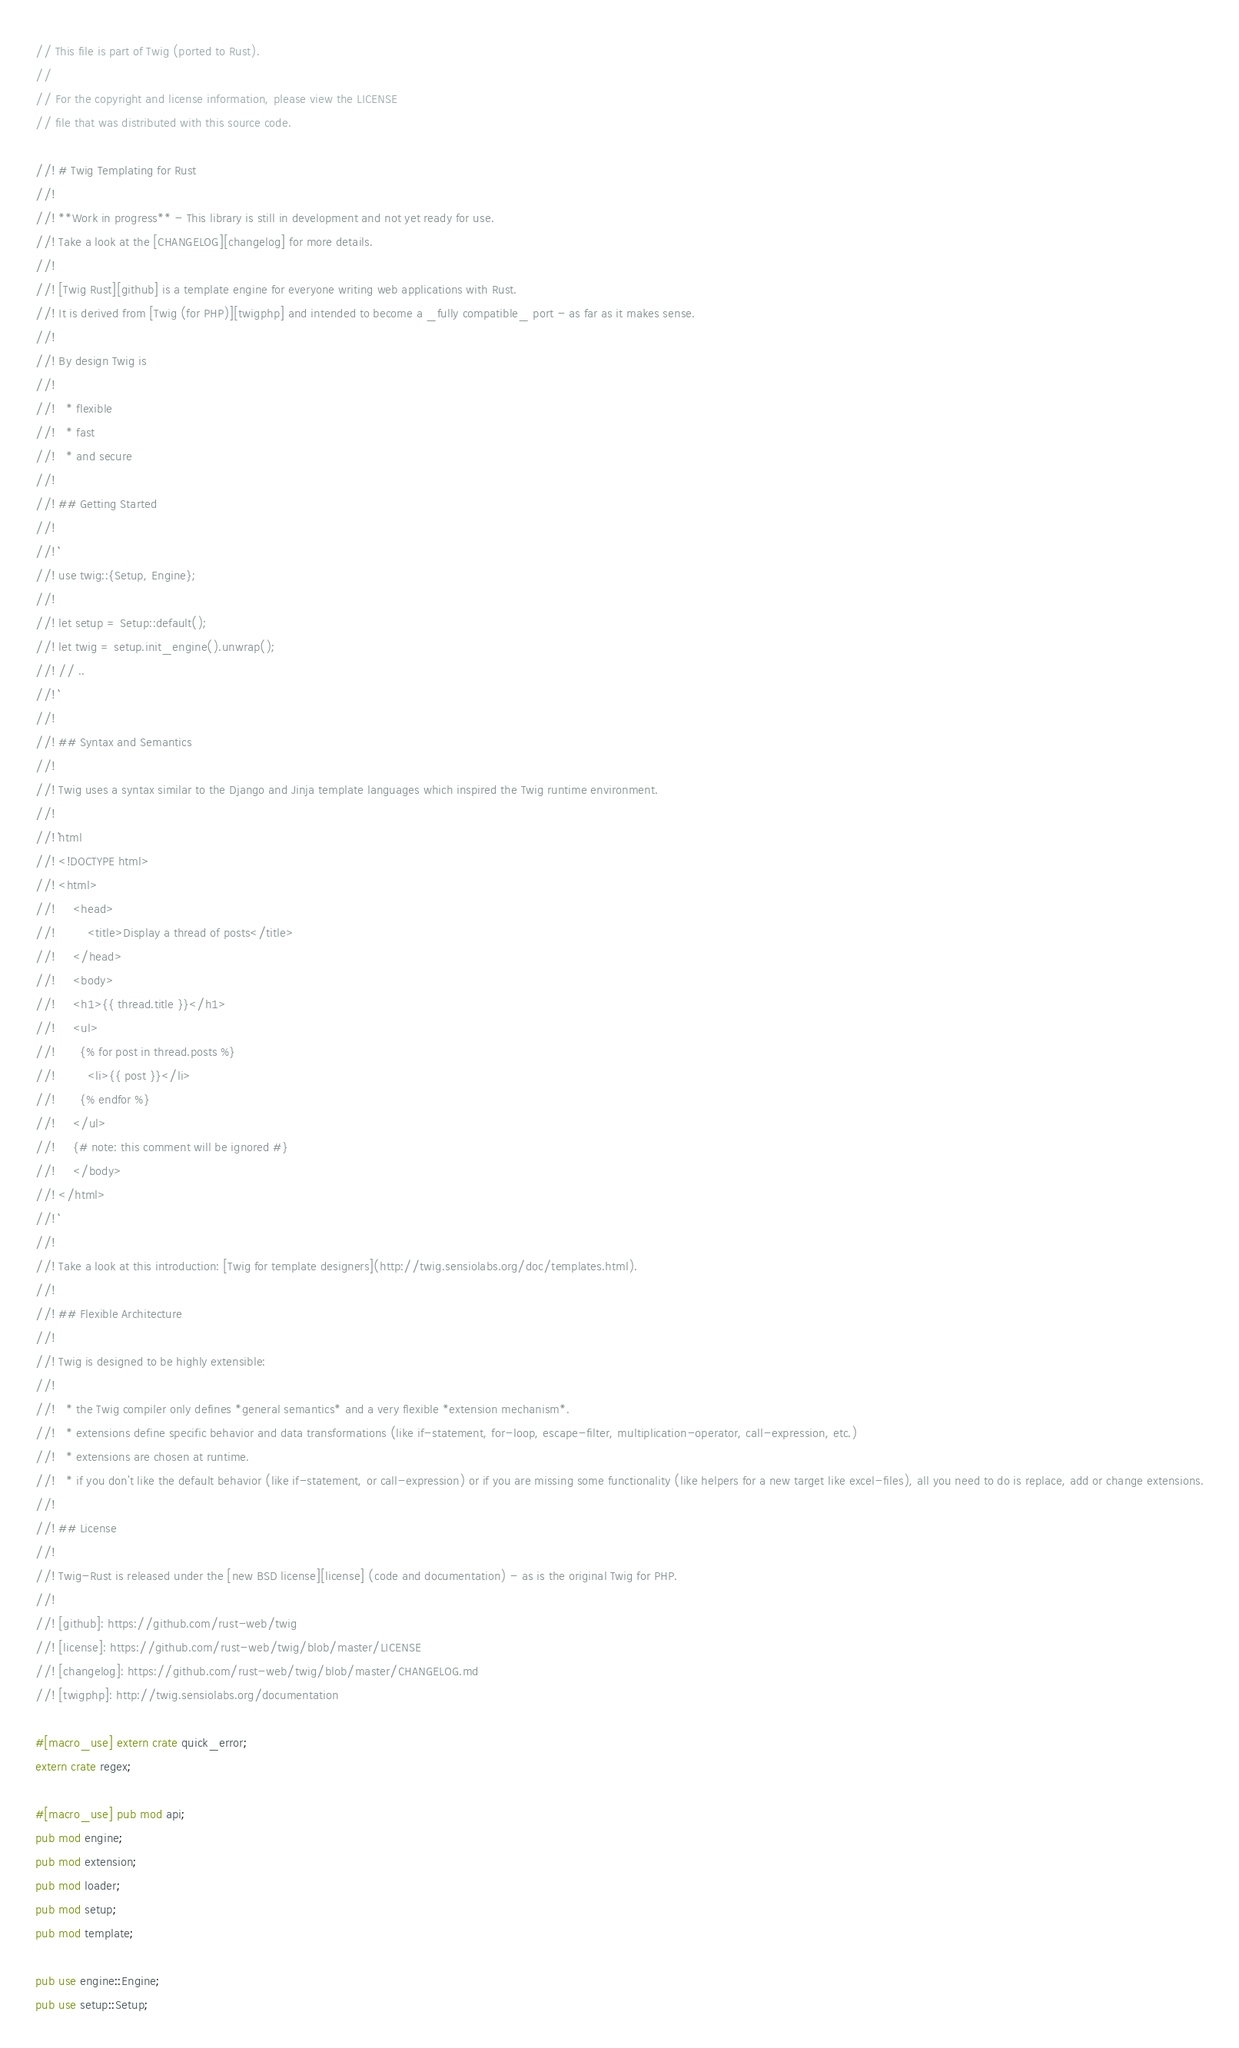Convert code to text. <code><loc_0><loc_0><loc_500><loc_500><_Rust_>// This file is part of Twig (ported to Rust).
//
// For the copyright and license information, please view the LICENSE
// file that was distributed with this source code.

//! # Twig Templating for Rust
//!
//! **Work in progress** - This library is still in development and not yet ready for use.
//! Take a look at the [CHANGELOG][changelog] for more details.
//!
//! [Twig Rust][github] is a template engine for everyone writing web applications with Rust.
//! It is derived from [Twig (for PHP)][twigphp] and intended to become a _fully compatible_ port - as far as it makes sense.
//!
//! By design Twig is
//!
//!   * flexible
//!   * fast
//!   * and secure
//!
//! ## Getting Started
//!
//! ```
//! use twig::{Setup, Engine};
//!
//! let setup = Setup::default();
//! let twig = setup.init_engine().unwrap();
//! // ..
//! ```
//!
//! ## Syntax and Semantics
//!
//! Twig uses a syntax similar to the Django and Jinja template languages which inspired the Twig runtime environment.
//!
//! ```html
//! <!DOCTYPE html>
//! <html>
//!     <head>
//!         <title>Display a thread of posts</title>
//!     </head>
//!     <body>
//!     <h1>{{ thread.title }}</h1>
//!     <ul>
//!       {% for post in thread.posts %}
//!         <li>{{ post }}</li>
//!       {% endfor %}
//!     </ul>
//!     {# note: this comment will be ignored #}
//!     </body>
//! </html>
//! ```
//!
//! Take a look at this introduction: [Twig for template designers](http://twig.sensiolabs.org/doc/templates.html).
//!
//! ## Flexible Architecture
//!
//! Twig is designed to be highly extensible:
//!
//!   * the Twig compiler only defines *general semantics* and a very flexible *extension mechanism*.
//!   * extensions define specific behavior and data transformations (like if-statement, for-loop, escape-filter, multiplication-operator, call-expression, etc.)
//!   * extensions are chosen at runtime.
//!   * if you don't like the default behavior (like if-statement, or call-expression) or if you are missing some functionality (like helpers for a new target like excel-files), all you need to do is replace, add or change extensions.
//!
//! ## License
//!
//! Twig-Rust is released under the [new BSD license][license] (code and documentation) - as is the original Twig for PHP.
//!
//! [github]: https://github.com/rust-web/twig
//! [license]: https://github.com/rust-web/twig/blob/master/LICENSE
//! [changelog]: https://github.com/rust-web/twig/blob/master/CHANGELOG.md
//! [twigphp]: http://twig.sensiolabs.org/documentation

#[macro_use] extern crate quick_error;
extern crate regex;

#[macro_use] pub mod api;
pub mod engine;
pub mod extension;
pub mod loader;
pub mod setup;
pub mod template;

pub use engine::Engine;
pub use setup::Setup;
</code> 